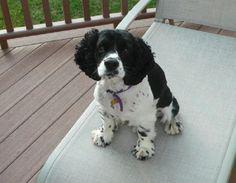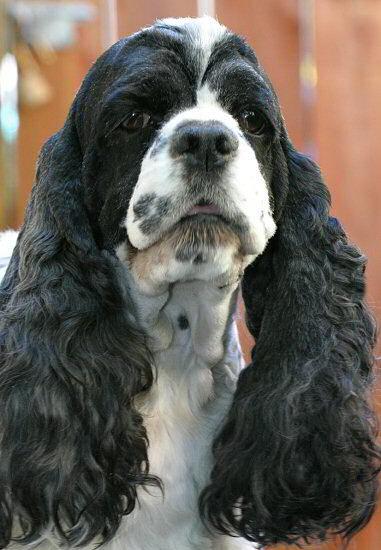The first image is the image on the left, the second image is the image on the right. For the images shown, is this caption "One image shows a spaniel with a white muzzle and black fur on eye and ear areas, and the other image shows two different colored spaniels posed close together." true? Answer yes or no. No. 